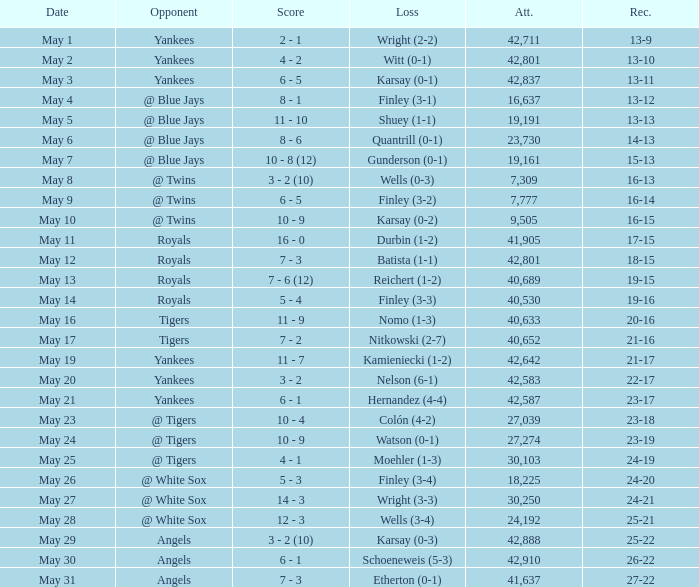What is the attendance for the game on May 25? 30103.0. 